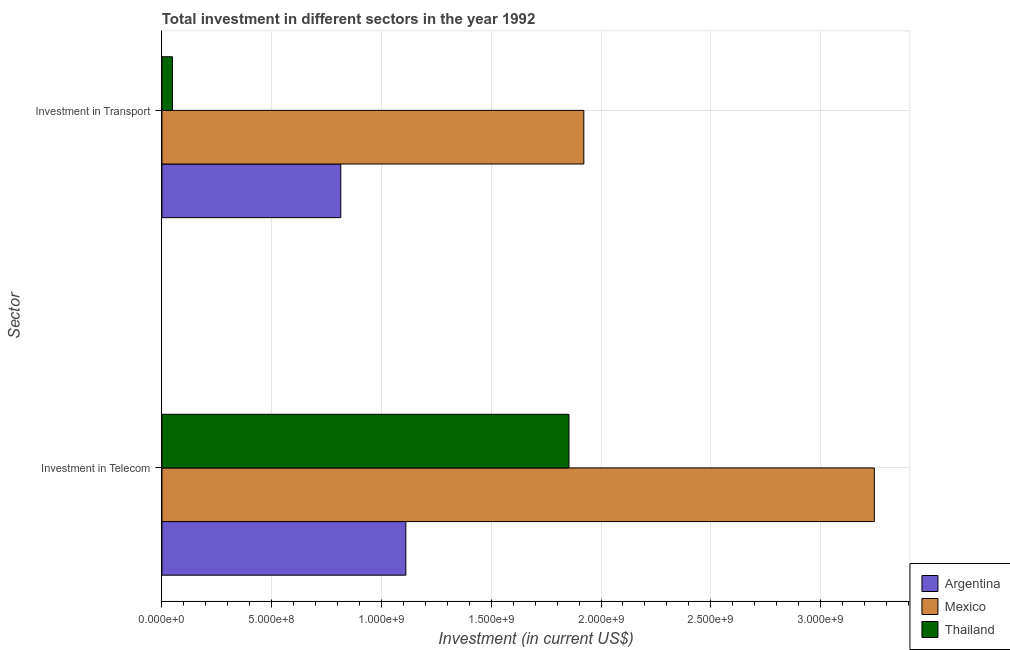How many different coloured bars are there?
Provide a short and direct response. 3. How many groups of bars are there?
Your response must be concise. 2. What is the label of the 1st group of bars from the top?
Offer a terse response. Investment in Transport. What is the investment in transport in Thailand?
Provide a succinct answer. 4.80e+07. Across all countries, what is the maximum investment in transport?
Your response must be concise. 1.92e+09. Across all countries, what is the minimum investment in transport?
Give a very brief answer. 4.80e+07. In which country was the investment in transport maximum?
Your response must be concise. Mexico. What is the total investment in transport in the graph?
Your answer should be compact. 2.78e+09. What is the difference between the investment in telecom in Mexico and that in Argentina?
Provide a short and direct response. 2.13e+09. What is the difference between the investment in transport in Argentina and the investment in telecom in Thailand?
Your answer should be compact. -1.04e+09. What is the average investment in telecom per country?
Offer a very short reply. 2.07e+09. What is the difference between the investment in telecom and investment in transport in Mexico?
Provide a succinct answer. 1.32e+09. What is the ratio of the investment in transport in Mexico to that in Argentina?
Make the answer very short. 2.36. In how many countries, is the investment in transport greater than the average investment in transport taken over all countries?
Provide a short and direct response. 1. What does the 1st bar from the top in Investment in Telecom represents?
Your response must be concise. Thailand. How many bars are there?
Provide a succinct answer. 6. Are all the bars in the graph horizontal?
Offer a very short reply. Yes. What is the difference between two consecutive major ticks on the X-axis?
Offer a terse response. 5.00e+08. Does the graph contain any zero values?
Offer a terse response. No. Does the graph contain grids?
Your answer should be very brief. Yes. Where does the legend appear in the graph?
Offer a terse response. Bottom right. How many legend labels are there?
Your response must be concise. 3. How are the legend labels stacked?
Your response must be concise. Vertical. What is the title of the graph?
Keep it short and to the point. Total investment in different sectors in the year 1992. Does "Guyana" appear as one of the legend labels in the graph?
Make the answer very short. No. What is the label or title of the X-axis?
Provide a succinct answer. Investment (in current US$). What is the label or title of the Y-axis?
Make the answer very short. Sector. What is the Investment (in current US$) of Argentina in Investment in Telecom?
Ensure brevity in your answer.  1.11e+09. What is the Investment (in current US$) of Mexico in Investment in Telecom?
Offer a terse response. 3.24e+09. What is the Investment (in current US$) of Thailand in Investment in Telecom?
Your answer should be compact. 1.85e+09. What is the Investment (in current US$) in Argentina in Investment in Transport?
Keep it short and to the point. 8.15e+08. What is the Investment (in current US$) of Mexico in Investment in Transport?
Keep it short and to the point. 1.92e+09. What is the Investment (in current US$) in Thailand in Investment in Transport?
Keep it short and to the point. 4.80e+07. Across all Sector, what is the maximum Investment (in current US$) in Argentina?
Provide a short and direct response. 1.11e+09. Across all Sector, what is the maximum Investment (in current US$) of Mexico?
Give a very brief answer. 3.24e+09. Across all Sector, what is the maximum Investment (in current US$) in Thailand?
Make the answer very short. 1.85e+09. Across all Sector, what is the minimum Investment (in current US$) in Argentina?
Keep it short and to the point. 8.15e+08. Across all Sector, what is the minimum Investment (in current US$) of Mexico?
Give a very brief answer. 1.92e+09. Across all Sector, what is the minimum Investment (in current US$) of Thailand?
Ensure brevity in your answer.  4.80e+07. What is the total Investment (in current US$) in Argentina in the graph?
Your response must be concise. 1.93e+09. What is the total Investment (in current US$) in Mexico in the graph?
Make the answer very short. 5.17e+09. What is the total Investment (in current US$) of Thailand in the graph?
Your answer should be compact. 1.90e+09. What is the difference between the Investment (in current US$) of Argentina in Investment in Telecom and that in Investment in Transport?
Ensure brevity in your answer.  2.96e+08. What is the difference between the Investment (in current US$) in Mexico in Investment in Telecom and that in Investment in Transport?
Your answer should be very brief. 1.32e+09. What is the difference between the Investment (in current US$) of Thailand in Investment in Telecom and that in Investment in Transport?
Provide a short and direct response. 1.81e+09. What is the difference between the Investment (in current US$) of Argentina in Investment in Telecom and the Investment (in current US$) of Mexico in Investment in Transport?
Your answer should be compact. -8.11e+08. What is the difference between the Investment (in current US$) in Argentina in Investment in Telecom and the Investment (in current US$) in Thailand in Investment in Transport?
Make the answer very short. 1.06e+09. What is the difference between the Investment (in current US$) in Mexico in Investment in Telecom and the Investment (in current US$) in Thailand in Investment in Transport?
Make the answer very short. 3.20e+09. What is the average Investment (in current US$) of Argentina per Sector?
Make the answer very short. 9.63e+08. What is the average Investment (in current US$) in Mexico per Sector?
Your response must be concise. 2.58e+09. What is the average Investment (in current US$) of Thailand per Sector?
Give a very brief answer. 9.51e+08. What is the difference between the Investment (in current US$) of Argentina and Investment (in current US$) of Mexico in Investment in Telecom?
Your response must be concise. -2.13e+09. What is the difference between the Investment (in current US$) in Argentina and Investment (in current US$) in Thailand in Investment in Telecom?
Give a very brief answer. -7.43e+08. What is the difference between the Investment (in current US$) of Mexico and Investment (in current US$) of Thailand in Investment in Telecom?
Your answer should be compact. 1.39e+09. What is the difference between the Investment (in current US$) of Argentina and Investment (in current US$) of Mexico in Investment in Transport?
Ensure brevity in your answer.  -1.11e+09. What is the difference between the Investment (in current US$) of Argentina and Investment (in current US$) of Thailand in Investment in Transport?
Ensure brevity in your answer.  7.67e+08. What is the difference between the Investment (in current US$) in Mexico and Investment (in current US$) in Thailand in Investment in Transport?
Offer a very short reply. 1.87e+09. What is the ratio of the Investment (in current US$) of Argentina in Investment in Telecom to that in Investment in Transport?
Your answer should be very brief. 1.36. What is the ratio of the Investment (in current US$) of Mexico in Investment in Telecom to that in Investment in Transport?
Ensure brevity in your answer.  1.69. What is the ratio of the Investment (in current US$) in Thailand in Investment in Telecom to that in Investment in Transport?
Keep it short and to the point. 38.62. What is the difference between the highest and the second highest Investment (in current US$) in Argentina?
Provide a short and direct response. 2.96e+08. What is the difference between the highest and the second highest Investment (in current US$) in Mexico?
Make the answer very short. 1.32e+09. What is the difference between the highest and the second highest Investment (in current US$) in Thailand?
Offer a terse response. 1.81e+09. What is the difference between the highest and the lowest Investment (in current US$) in Argentina?
Your answer should be compact. 2.96e+08. What is the difference between the highest and the lowest Investment (in current US$) in Mexico?
Offer a terse response. 1.32e+09. What is the difference between the highest and the lowest Investment (in current US$) in Thailand?
Give a very brief answer. 1.81e+09. 